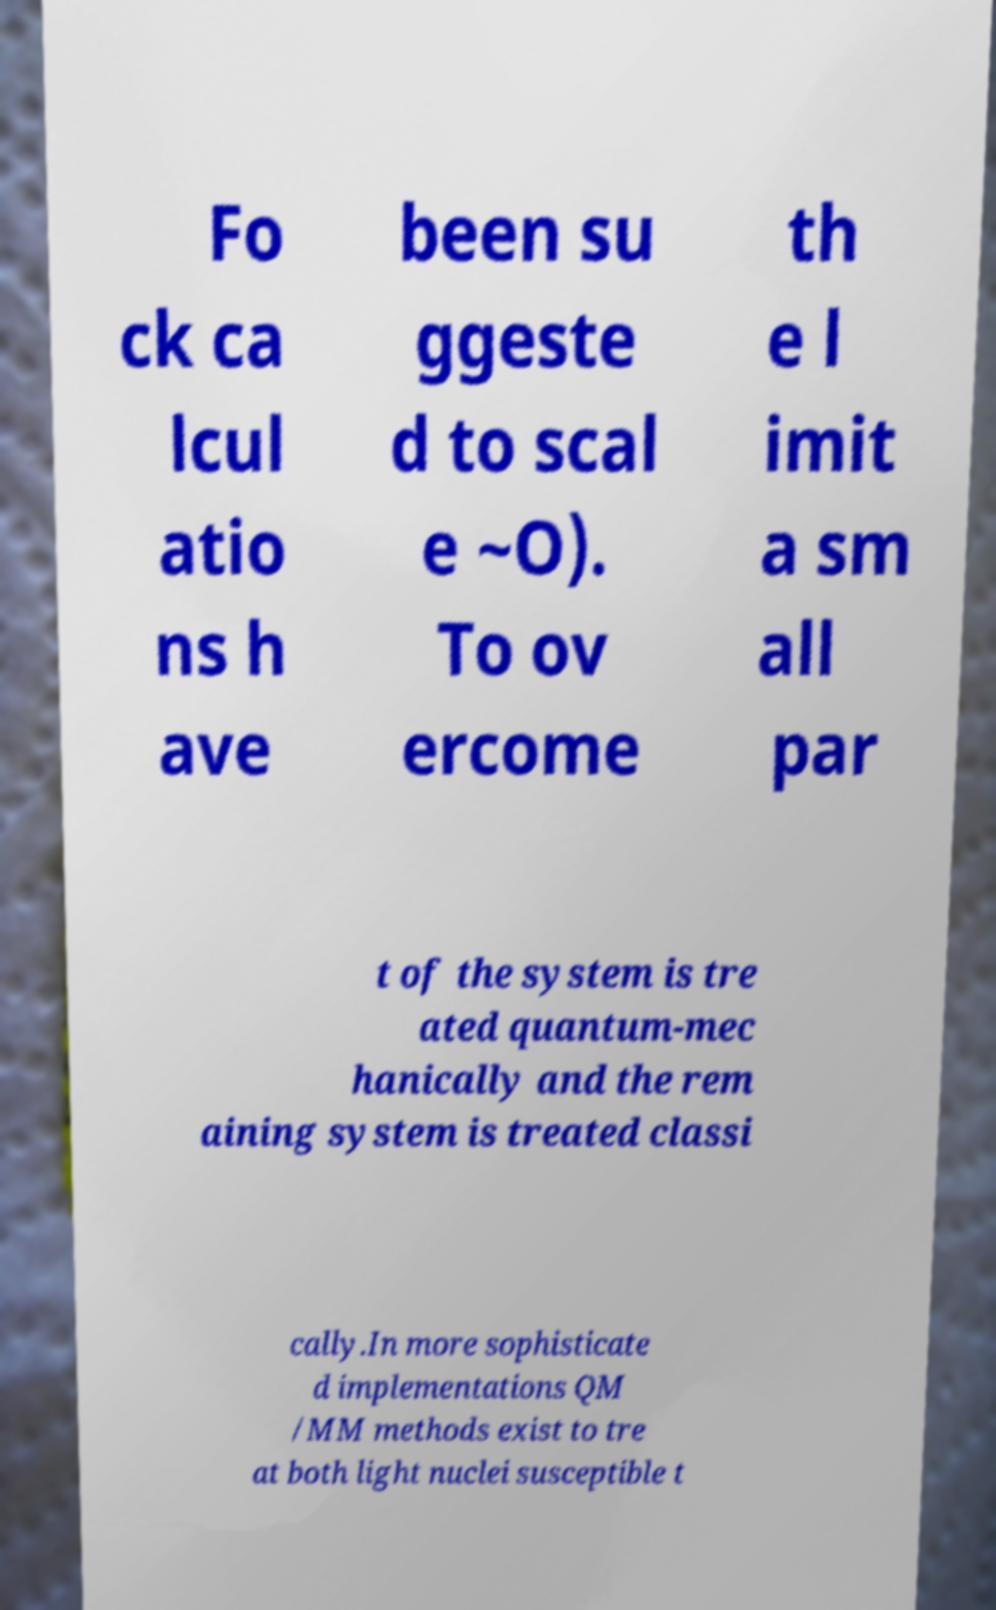There's text embedded in this image that I need extracted. Can you transcribe it verbatim? Fo ck ca lcul atio ns h ave been su ggeste d to scal e ~O). To ov ercome th e l imit a sm all par t of the system is tre ated quantum-mec hanically and the rem aining system is treated classi cally.In more sophisticate d implementations QM /MM methods exist to tre at both light nuclei susceptible t 